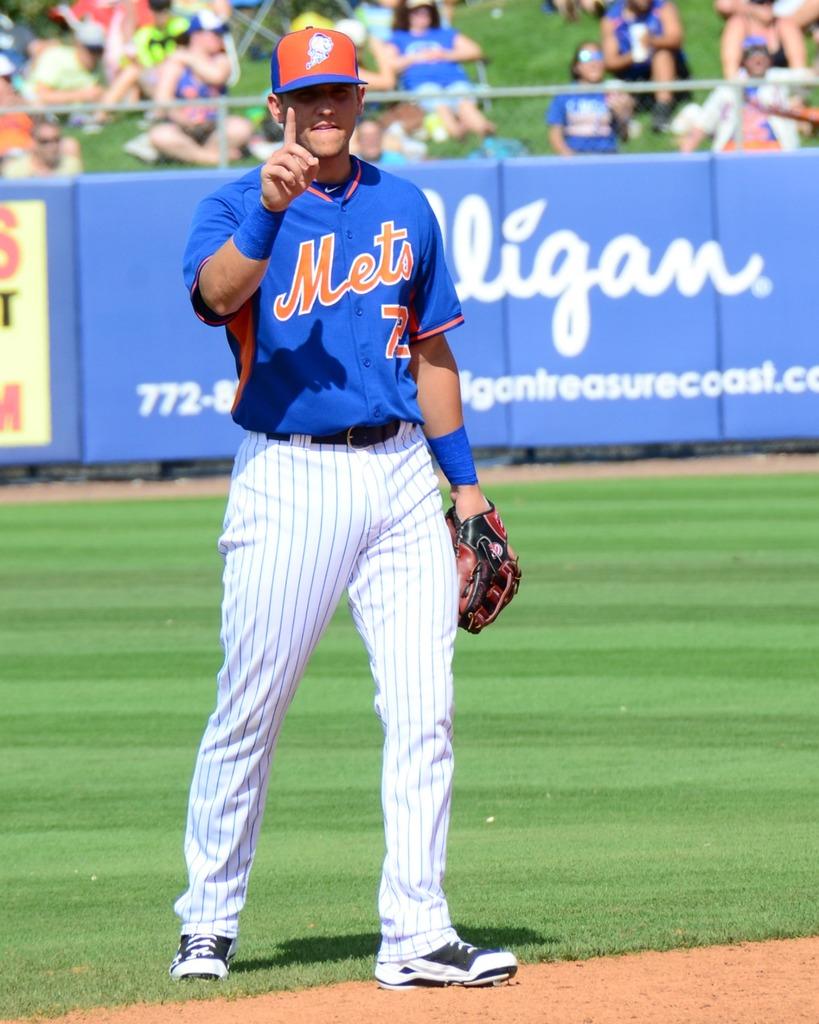What is the team name written on the mans jersey?
Keep it short and to the point. Mets. 